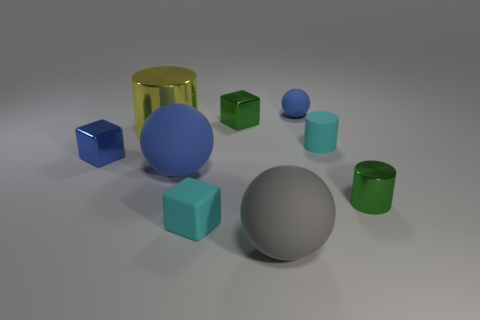There is a blue thing that is on the right side of the small green metallic block behind the large sphere to the right of the rubber cube; how big is it?
Ensure brevity in your answer.  Small. Does the blue metallic block have the same size as the blue ball that is behind the yellow metal thing?
Offer a very short reply. Yes. What is the color of the metallic cylinder behind the green shiny cylinder?
Give a very brief answer. Yellow. What shape is the small thing that is the same color as the tiny matte cube?
Provide a succinct answer. Cylinder. There is a tiny metal thing in front of the blue shiny thing; what is its shape?
Make the answer very short. Cylinder. What number of green objects are either metal blocks or large cylinders?
Give a very brief answer. 1. Is the material of the yellow cylinder the same as the tiny cyan cylinder?
Make the answer very short. No. What number of small blocks are in front of the large gray matte thing?
Offer a terse response. 0. There is a big object that is both in front of the cyan rubber cylinder and behind the gray matte thing; what material is it?
Provide a succinct answer. Rubber. What number of cylinders are cyan matte things or gray rubber things?
Provide a succinct answer. 1. 